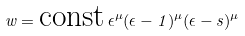<formula> <loc_0><loc_0><loc_500><loc_500>w = \text {const} \, \epsilon ^ { \mu } ( \epsilon - 1 ) ^ { \mu } ( \epsilon - s ) ^ { \mu }</formula> 